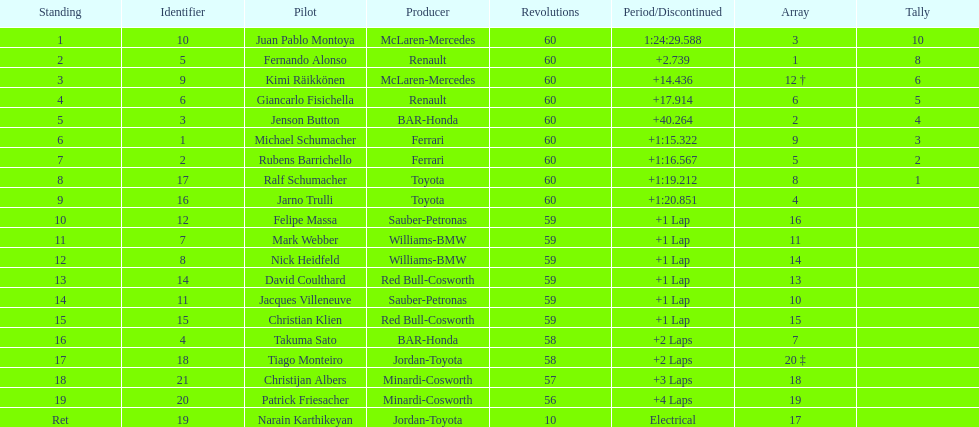Which driver in the top 8, drives a mclaran-mercedes but is not in first place? Kimi Räikkönen. 